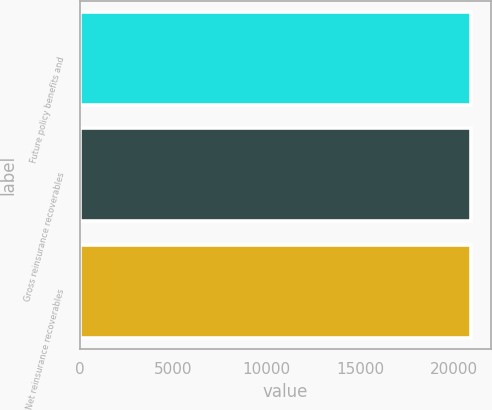<chart> <loc_0><loc_0><loc_500><loc_500><bar_chart><fcel>Future policy benefits and<fcel>Gross reinsurance recoverables<fcel>Net reinsurance recoverables<nl><fcel>20938<fcel>20938.1<fcel>20938.2<nl></chart> 